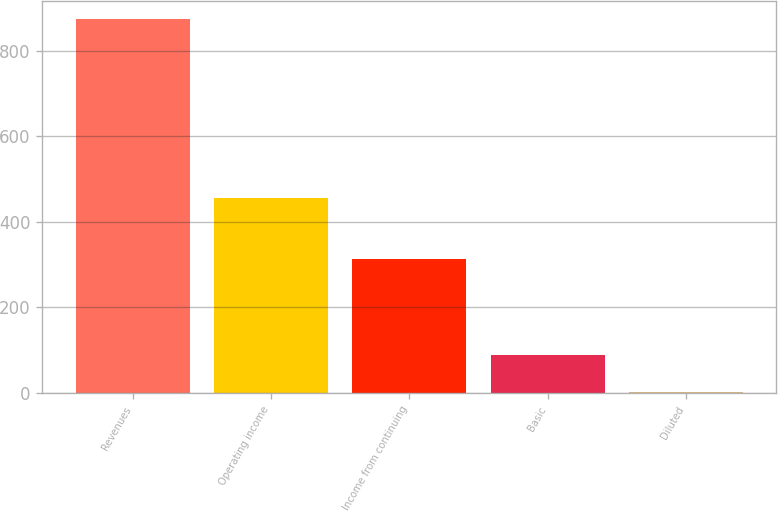Convert chart. <chart><loc_0><loc_0><loc_500><loc_500><bar_chart><fcel>Revenues<fcel>Operating income<fcel>Income from continuing<fcel>Basic<fcel>Diluted<nl><fcel>874<fcel>457<fcel>312<fcel>89.12<fcel>1.91<nl></chart> 